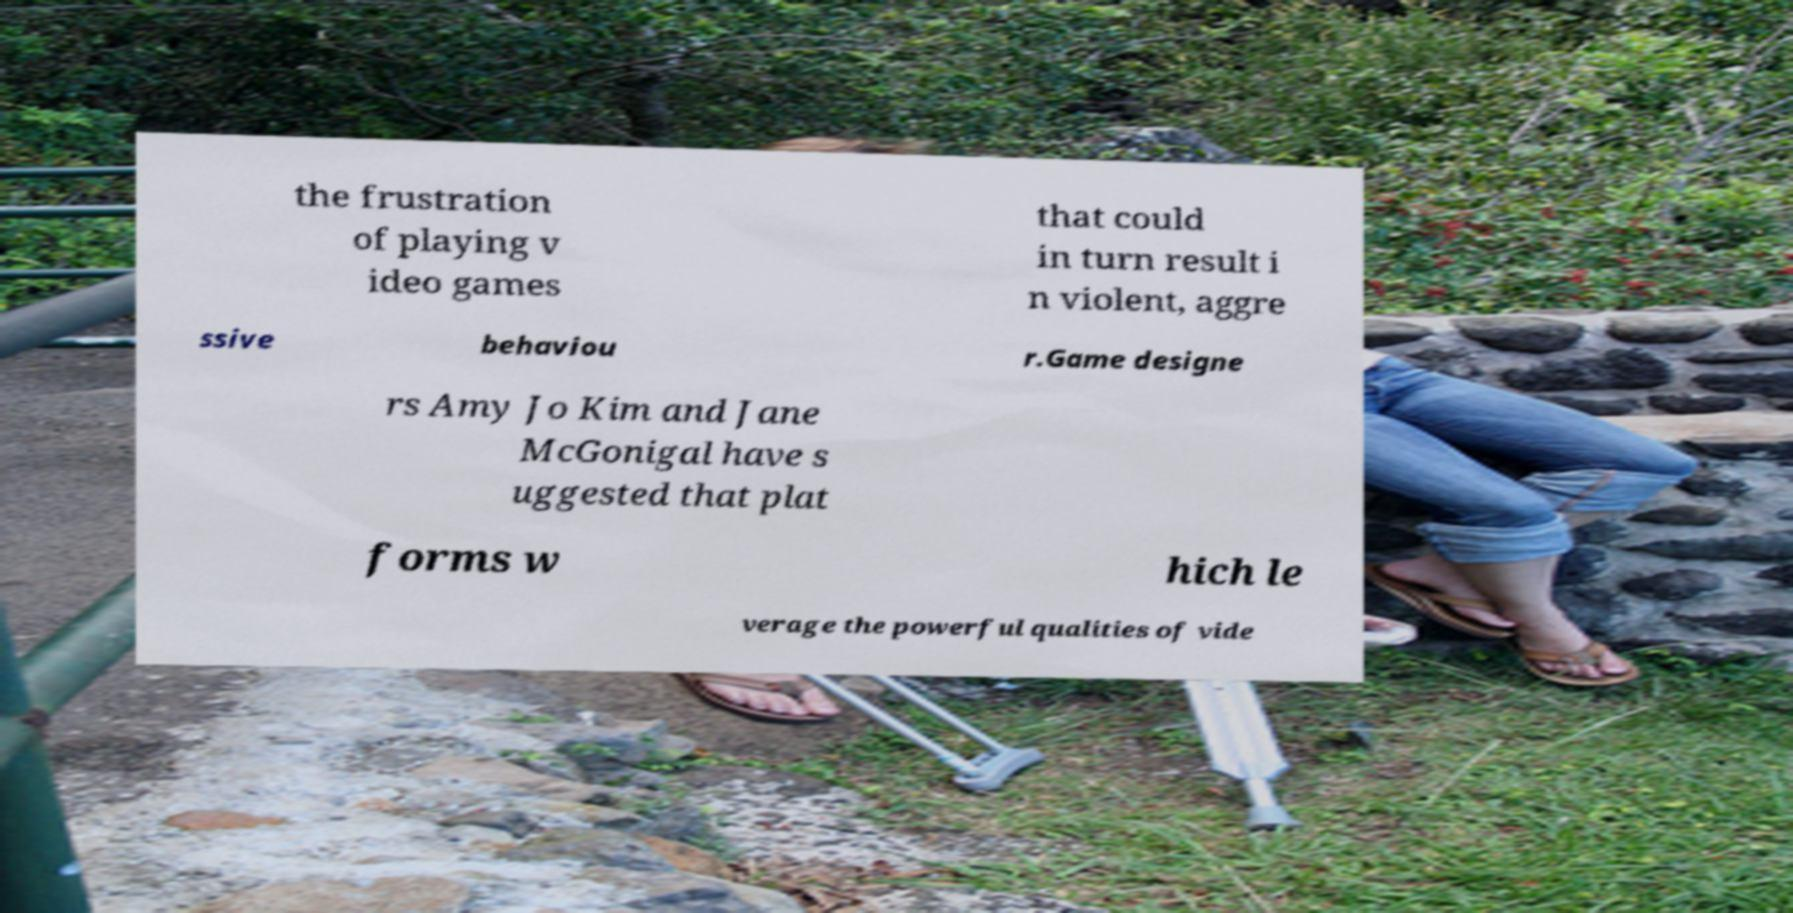Could you assist in decoding the text presented in this image and type it out clearly? the frustration of playing v ideo games that could in turn result i n violent, aggre ssive behaviou r.Game designe rs Amy Jo Kim and Jane McGonigal have s uggested that plat forms w hich le verage the powerful qualities of vide 